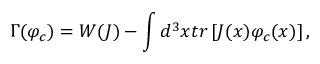<formula> <loc_0><loc_0><loc_500><loc_500>\Gamma ( \varphi _ { c } ) = W ( J ) - \int d ^ { 3 } x t r \left [ J ( x ) \varphi _ { c } ( x ) \right ] ,</formula> 